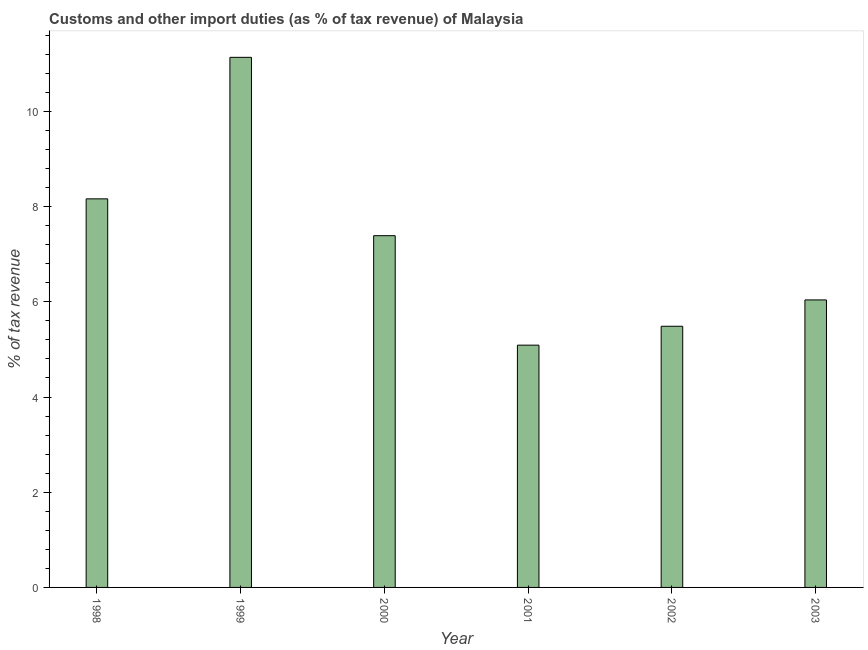What is the title of the graph?
Your answer should be compact. Customs and other import duties (as % of tax revenue) of Malaysia. What is the label or title of the X-axis?
Your response must be concise. Year. What is the label or title of the Y-axis?
Your response must be concise. % of tax revenue. What is the customs and other import duties in 2002?
Offer a very short reply. 5.49. Across all years, what is the maximum customs and other import duties?
Give a very brief answer. 11.14. Across all years, what is the minimum customs and other import duties?
Give a very brief answer. 5.09. In which year was the customs and other import duties minimum?
Your answer should be very brief. 2001. What is the sum of the customs and other import duties?
Offer a terse response. 43.3. What is the difference between the customs and other import duties in 1998 and 2002?
Your answer should be compact. 2.68. What is the average customs and other import duties per year?
Give a very brief answer. 7.22. What is the median customs and other import duties?
Provide a succinct answer. 6.71. What is the ratio of the customs and other import duties in 1998 to that in 2002?
Your answer should be compact. 1.49. Is the customs and other import duties in 1998 less than that in 1999?
Offer a very short reply. Yes. Is the difference between the customs and other import duties in 1998 and 1999 greater than the difference between any two years?
Ensure brevity in your answer.  No. What is the difference between the highest and the second highest customs and other import duties?
Your response must be concise. 2.97. What is the difference between the highest and the lowest customs and other import duties?
Your response must be concise. 6.05. In how many years, is the customs and other import duties greater than the average customs and other import duties taken over all years?
Offer a very short reply. 3. How many years are there in the graph?
Your answer should be very brief. 6. What is the difference between two consecutive major ticks on the Y-axis?
Keep it short and to the point. 2. Are the values on the major ticks of Y-axis written in scientific E-notation?
Provide a succinct answer. No. What is the % of tax revenue of 1998?
Make the answer very short. 8.16. What is the % of tax revenue in 1999?
Provide a succinct answer. 11.14. What is the % of tax revenue in 2000?
Ensure brevity in your answer.  7.39. What is the % of tax revenue in 2001?
Ensure brevity in your answer.  5.09. What is the % of tax revenue in 2002?
Your response must be concise. 5.49. What is the % of tax revenue in 2003?
Provide a succinct answer. 6.04. What is the difference between the % of tax revenue in 1998 and 1999?
Give a very brief answer. -2.97. What is the difference between the % of tax revenue in 1998 and 2000?
Provide a succinct answer. 0.77. What is the difference between the % of tax revenue in 1998 and 2001?
Make the answer very short. 3.07. What is the difference between the % of tax revenue in 1998 and 2002?
Your answer should be compact. 2.68. What is the difference between the % of tax revenue in 1998 and 2003?
Your answer should be compact. 2.12. What is the difference between the % of tax revenue in 1999 and 2000?
Your response must be concise. 3.75. What is the difference between the % of tax revenue in 1999 and 2001?
Your response must be concise. 6.05. What is the difference between the % of tax revenue in 1999 and 2002?
Your answer should be compact. 5.65. What is the difference between the % of tax revenue in 1999 and 2003?
Give a very brief answer. 5.1. What is the difference between the % of tax revenue in 2000 and 2001?
Make the answer very short. 2.3. What is the difference between the % of tax revenue in 2000 and 2002?
Your answer should be very brief. 1.9. What is the difference between the % of tax revenue in 2000 and 2003?
Provide a short and direct response. 1.35. What is the difference between the % of tax revenue in 2001 and 2002?
Your answer should be compact. -0.4. What is the difference between the % of tax revenue in 2001 and 2003?
Offer a very short reply. -0.95. What is the difference between the % of tax revenue in 2002 and 2003?
Make the answer very short. -0.55. What is the ratio of the % of tax revenue in 1998 to that in 1999?
Make the answer very short. 0.73. What is the ratio of the % of tax revenue in 1998 to that in 2000?
Your response must be concise. 1.1. What is the ratio of the % of tax revenue in 1998 to that in 2001?
Your answer should be compact. 1.6. What is the ratio of the % of tax revenue in 1998 to that in 2002?
Offer a terse response. 1.49. What is the ratio of the % of tax revenue in 1998 to that in 2003?
Offer a very short reply. 1.35. What is the ratio of the % of tax revenue in 1999 to that in 2000?
Keep it short and to the point. 1.51. What is the ratio of the % of tax revenue in 1999 to that in 2001?
Give a very brief answer. 2.19. What is the ratio of the % of tax revenue in 1999 to that in 2002?
Provide a short and direct response. 2.03. What is the ratio of the % of tax revenue in 1999 to that in 2003?
Provide a succinct answer. 1.84. What is the ratio of the % of tax revenue in 2000 to that in 2001?
Your answer should be very brief. 1.45. What is the ratio of the % of tax revenue in 2000 to that in 2002?
Provide a short and direct response. 1.35. What is the ratio of the % of tax revenue in 2000 to that in 2003?
Give a very brief answer. 1.22. What is the ratio of the % of tax revenue in 2001 to that in 2002?
Offer a very short reply. 0.93. What is the ratio of the % of tax revenue in 2001 to that in 2003?
Offer a terse response. 0.84. What is the ratio of the % of tax revenue in 2002 to that in 2003?
Ensure brevity in your answer.  0.91. 